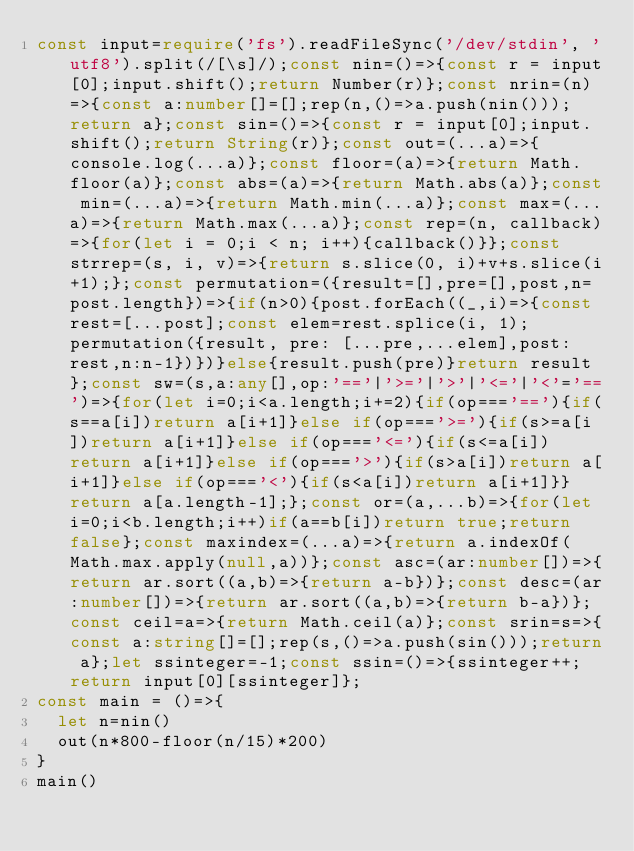Convert code to text. <code><loc_0><loc_0><loc_500><loc_500><_TypeScript_>const input=require('fs').readFileSync('/dev/stdin', 'utf8').split(/[\s]/);const nin=()=>{const r = input[0];input.shift();return Number(r)};const nrin=(n)=>{const a:number[]=[];rep(n,()=>a.push(nin()));return a};const sin=()=>{const r = input[0];input.shift();return String(r)};const out=(...a)=>{console.log(...a)};const floor=(a)=>{return Math.floor(a)};const abs=(a)=>{return Math.abs(a)};const min=(...a)=>{return Math.min(...a)};const max=(...a)=>{return Math.max(...a)};const rep=(n, callback)=>{for(let i = 0;i < n; i++){callback()}};const strrep=(s, i, v)=>{return s.slice(0, i)+v+s.slice(i+1);};const permutation=({result=[],pre=[],post,n=post.length})=>{if(n>0){post.forEach((_,i)=>{const rest=[...post];const elem=rest.splice(i, 1);permutation({result, pre: [...pre,...elem],post:rest,n:n-1})})}else{result.push(pre)}return result};const sw=(s,a:any[],op:'=='|'>='|'>'|'<='|'<'='==')=>{for(let i=0;i<a.length;i+=2){if(op==='=='){if(s==a[i])return a[i+1]}else if(op==='>='){if(s>=a[i])return a[i+1]}else if(op==='<='){if(s<=a[i])return a[i+1]}else if(op==='>'){if(s>a[i])return a[i+1]}else if(op==='<'){if(s<a[i])return a[i+1]}}return a[a.length-1];};const or=(a,...b)=>{for(let i=0;i<b.length;i++)if(a==b[i])return true;return false};const maxindex=(...a)=>{return a.indexOf(Math.max.apply(null,a))};const asc=(ar:number[])=>{return ar.sort((a,b)=>{return a-b})};const desc=(ar:number[])=>{return ar.sort((a,b)=>{return b-a})};const ceil=a=>{return Math.ceil(a)};const srin=s=>{const a:string[]=[];rep(s,()=>a.push(sin()));return a};let ssinteger=-1;const ssin=()=>{ssinteger++;return input[0][ssinteger]};
const main = ()=>{
  let n=nin()
  out(n*800-floor(n/15)*200)
}
main()</code> 